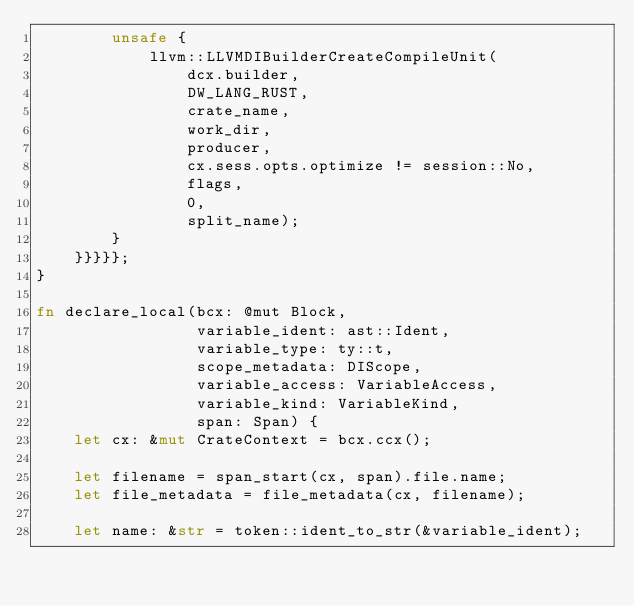<code> <loc_0><loc_0><loc_500><loc_500><_Rust_>        unsafe {
            llvm::LLVMDIBuilderCreateCompileUnit(
                dcx.builder,
                DW_LANG_RUST,
                crate_name,
                work_dir,
                producer,
                cx.sess.opts.optimize != session::No,
                flags,
                0,
                split_name);
        }
    }}}}};
}

fn declare_local(bcx: @mut Block,
                 variable_ident: ast::Ident,
                 variable_type: ty::t,
                 scope_metadata: DIScope,
                 variable_access: VariableAccess,
                 variable_kind: VariableKind,
                 span: Span) {
    let cx: &mut CrateContext = bcx.ccx();

    let filename = span_start(cx, span).file.name;
    let file_metadata = file_metadata(cx, filename);

    let name: &str = token::ident_to_str(&variable_ident);</code> 